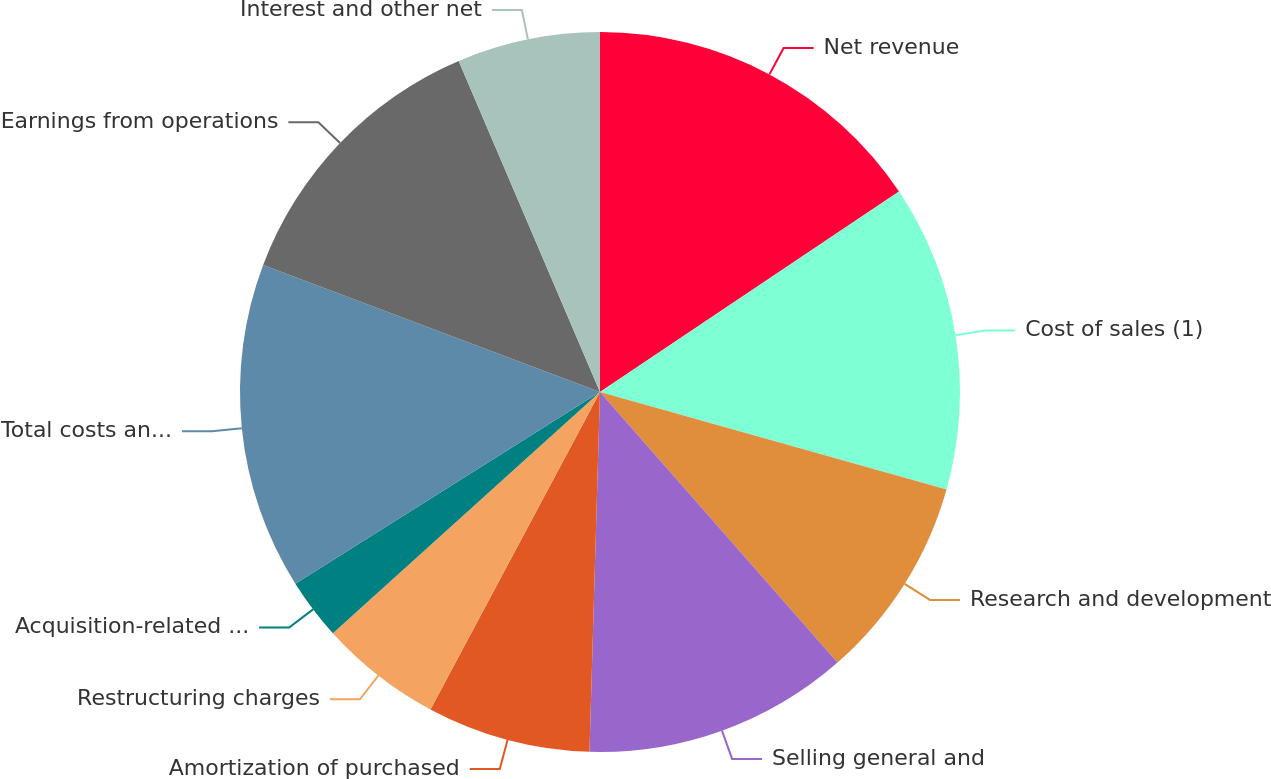Convert chart. <chart><loc_0><loc_0><loc_500><loc_500><pie_chart><fcel>Net revenue<fcel>Cost of sales (1)<fcel>Research and development<fcel>Selling general and<fcel>Amortization of purchased<fcel>Restructuring charges<fcel>Acquisition-related charges<fcel>Total costs and expenses<fcel>Earnings from operations<fcel>Interest and other net<nl><fcel>15.6%<fcel>13.76%<fcel>9.17%<fcel>11.93%<fcel>7.34%<fcel>5.5%<fcel>2.75%<fcel>14.68%<fcel>12.84%<fcel>6.42%<nl></chart> 